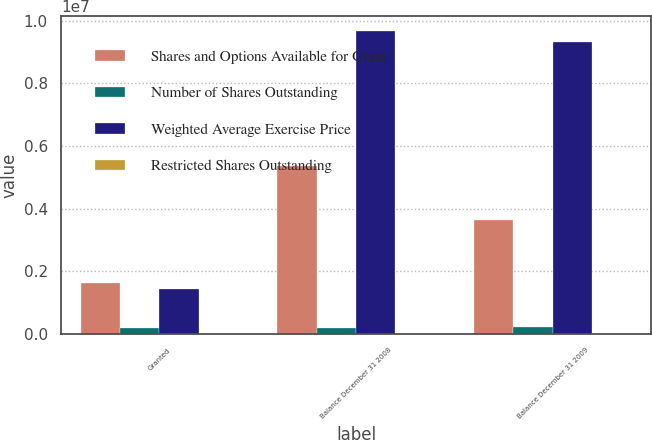Convert chart. <chart><loc_0><loc_0><loc_500><loc_500><stacked_bar_chart><ecel><fcel>Granted<fcel>Balance December 31 2008<fcel>Balance December 31 2009<nl><fcel>Shares and Options Available for Grant<fcel>1.63242e+06<fcel>5.37493e+06<fcel>3.6428e+06<nl><fcel>Number of Shares Outstanding<fcel>190000<fcel>190000<fcel>202000<nl><fcel>Weighted Average Exercise Price<fcel>1.44242e+06<fcel>9.66359e+06<fcel>9.32941e+06<nl><fcel>Restricted Shares Outstanding<fcel>19.13<fcel>7.27<fcel>8.81<nl></chart> 